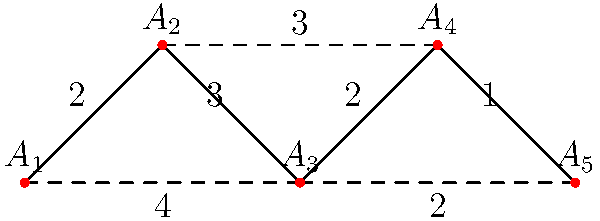Given the graph representing animal migration patterns collected by drones, where vertices $A_1$ to $A_5$ represent different locations and edges represent migration routes with weights indicating the frequency of animal movement, which traversal algorithm would be most efficient to find the path with the highest total migration frequency from $A_1$ to $A_5$, and what is the total frequency of this path? To find the path with the highest total migration frequency from $A_1$ to $A_5$, we should use Dijkstra's algorithm with a slight modification. Instead of finding the shortest path, we'll find the path with the highest sum of weights.

Steps:
1. Initialize distances: $d(A_1) = 0$, $d(A_i) = -\infty$ for $i \neq 1$
2. Initialize a priority queue Q with all vertices, prioritized by their distance values
3. While Q is not empty:
   a. Extract vertex u with the highest distance
   b. For each neighbor v of u:
      If $d(v) < d(u) + weight(u,v)$, then $d(v) = d(u) + weight(u,v)$

4. Applying the algorithm:
   - Start at $A_1$: $d(A_1) = 0$
   - Update neighbors: $d(A_2) = 2$, $d(A_3) = 4$
   - Move to $A_3$: $d(A_3) = 4$
   - Update $d(A_4) = 4 + 2 = 6$, $d(A_5) = 4 + 2 = 6$
   - Move to $A_4$: $d(A_4) = 6$
   - Update $d(A_5) = 6 + 1 = 7$

5. The path with the highest total frequency is $A_1 \rightarrow A_3 \rightarrow A_4 \rightarrow A_5$
6. The total frequency of this path is 7 (4 + 2 + 1)
Answer: Dijkstra's algorithm (modified for maximum weight); 7 